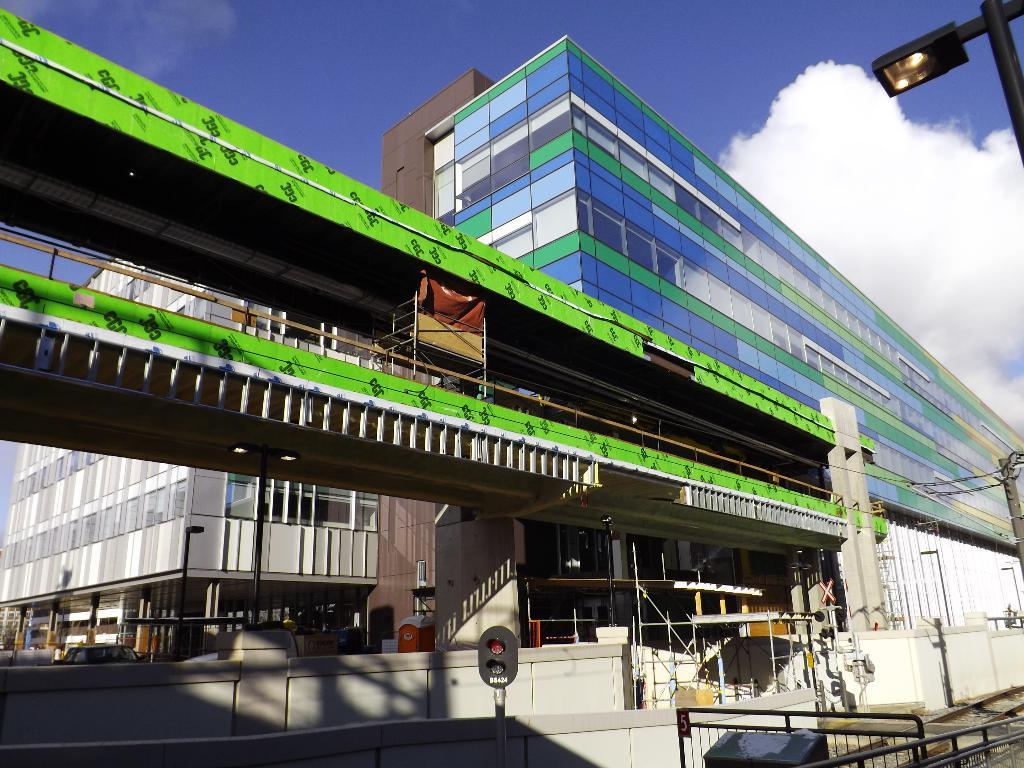What type of structures can be seen in the image? There are buildings in the image. What can be seen illuminating the area in the image? There is a light visible in the image. What is visible in the background of the image? The sky is visible in the background of the image. What can be observed in the sky in the image? Clouds are present in the sky. What type of leaf is being used as a cushion in the image? There is no leaf or cushion present in the image. 